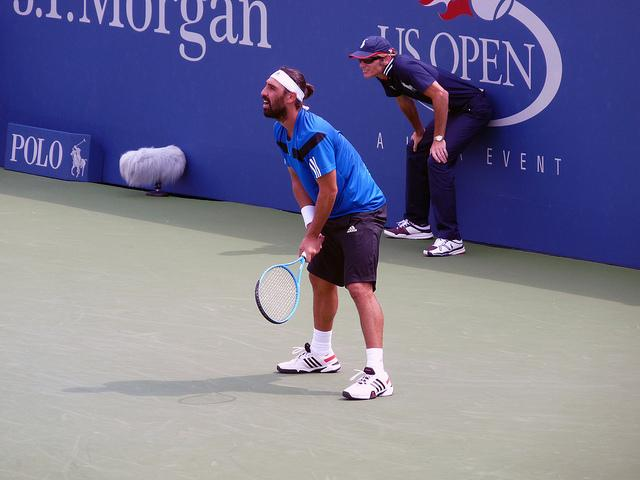What do the sunglasses worn here serve as? protection 